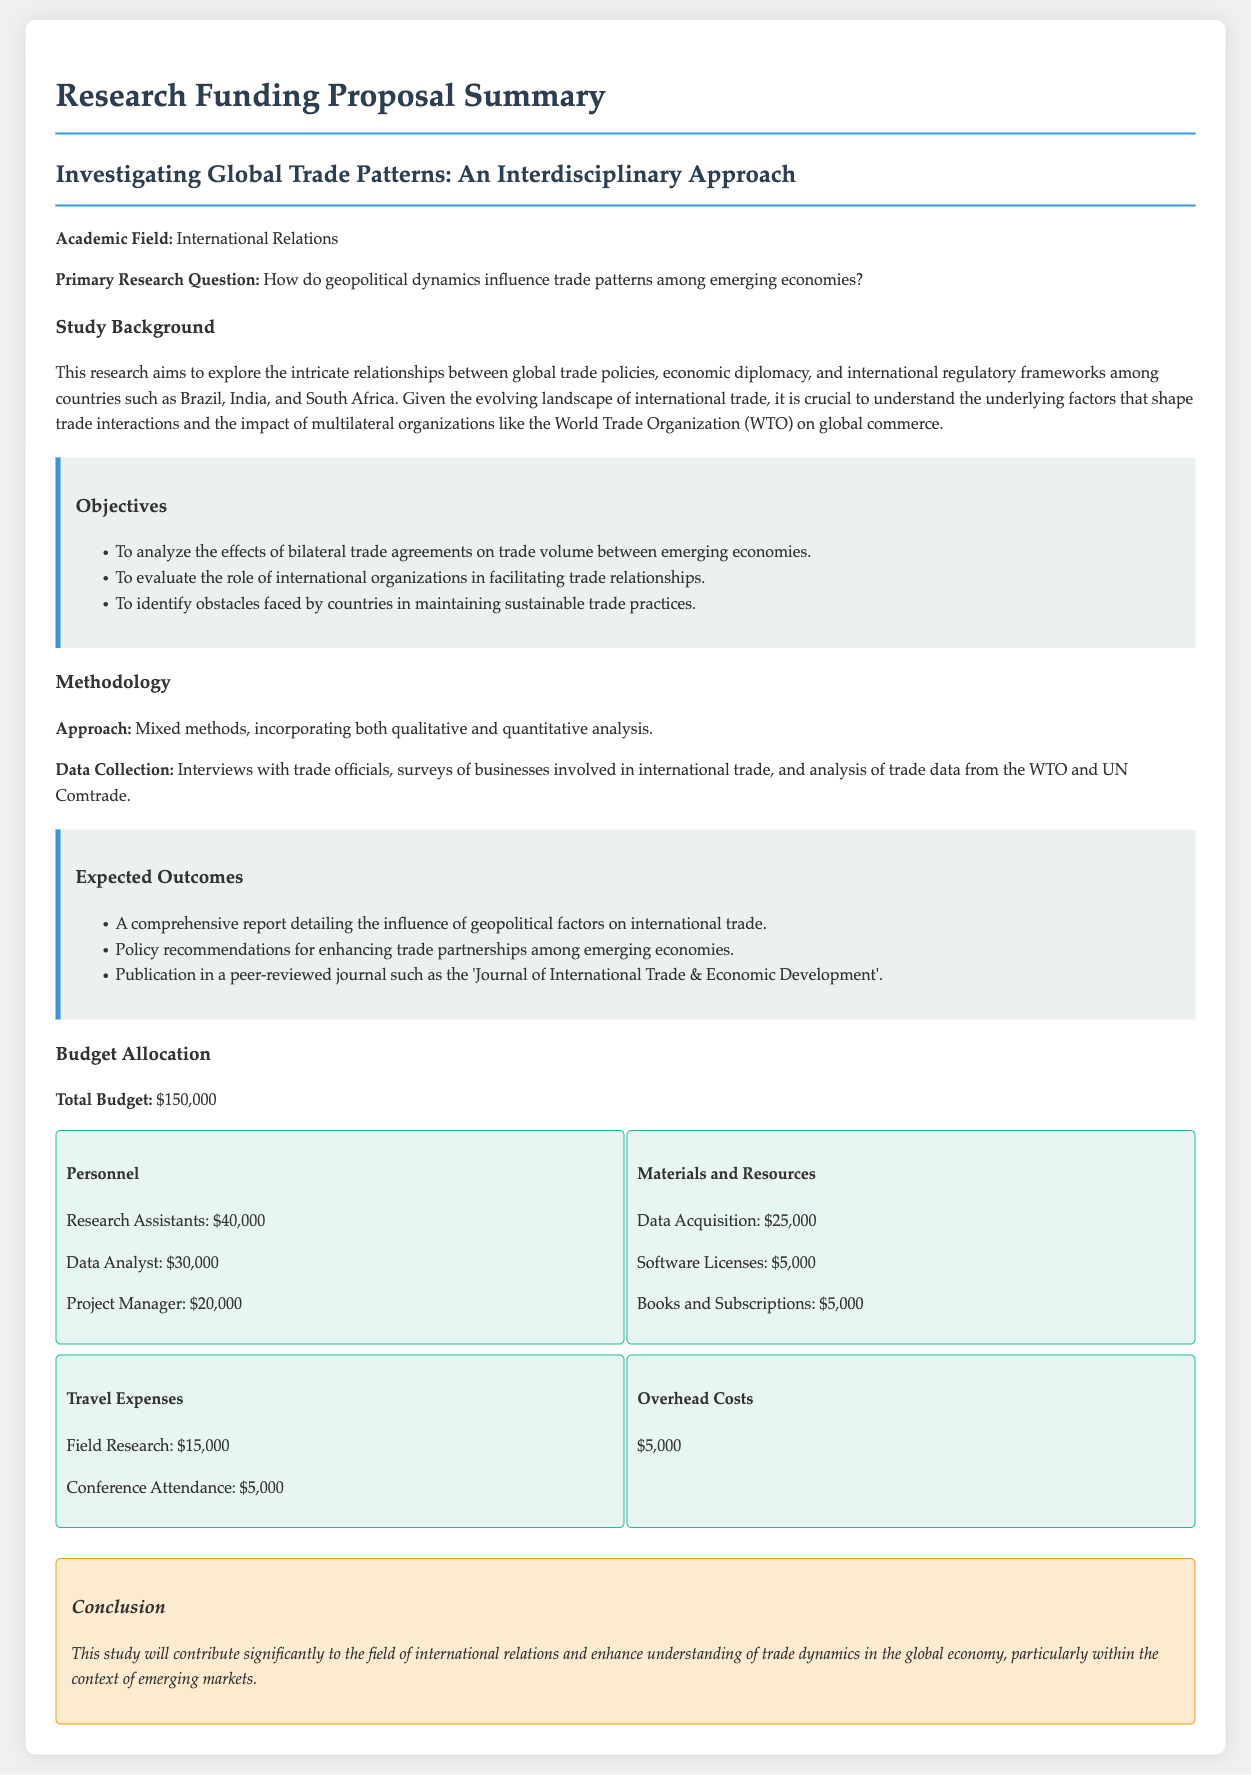What is the total budget? The total budget is stated explicitly in the document as the overall funding required for the research, which is $150,000.
Answer: $150,000 What are the primary countries of focus in this research? The document explicitly mentions the countries of focus in the study which are Brazil, India, and South Africa.
Answer: Brazil, India, and South Africa What is one of the expected outcomes of the research? The document lists several expected outcomes, one of which is the publication of research findings in a specific journal.
Answer: Publication in a peer-reviewed journal How much is allocated to research assistants? The budget section provides specific figures for personnel costs, with research assistants allocated $40,000.
Answer: $40,000 What methodology approach is used in the study? The methodology section describes the overall approach taken in the study as a mixed methods approach, combining qualitative and quantitative analysis.
Answer: Mixed methods How much is allocated for data acquisition? The budget breakdown includes data acquisition costs, specified as $25,000.
Answer: $25,000 Which international organization is mentioned in relation to trade? The document references the World Trade Organization (WTO) as an influential organization in international trade.
Answer: World Trade Organization (WTO) What is the focus of the primary research question? The primary research question focuses on understanding the influence of geopolitical dynamics on trade patterns among emerging economies.
Answer: Geopolitical dynamics influence trade patterns What type of data collection methods will be employed? The document mentions various methods of data collection to be used, including interviews with trade officials and surveys of businesses.
Answer: Interviews and surveys 